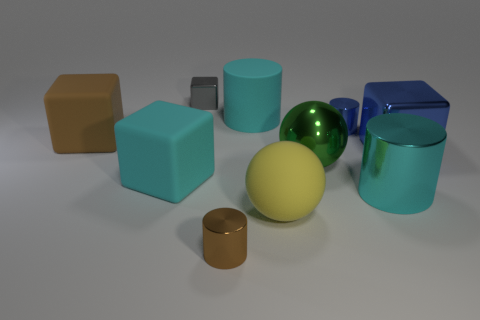Subtract all cyan matte cylinders. How many cylinders are left? 3 Subtract all yellow balls. How many balls are left? 1 Subtract all balls. How many objects are left? 8 Subtract all purple cubes. How many cyan cylinders are left? 2 Subtract all yellow cubes. Subtract all green balls. How many cubes are left? 4 Subtract all blue metallic objects. Subtract all large yellow blocks. How many objects are left? 8 Add 5 brown cubes. How many brown cubes are left? 6 Add 2 big purple matte blocks. How many big purple matte blocks exist? 2 Subtract 0 yellow cylinders. How many objects are left? 10 Subtract 1 cylinders. How many cylinders are left? 3 